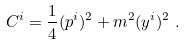Convert formula to latex. <formula><loc_0><loc_0><loc_500><loc_500>C ^ { i } & = \frac { 1 } { 4 } ( p ^ { i } ) ^ { 2 } + m ^ { 2 } ( y ^ { i } ) ^ { 2 } \ .</formula> 